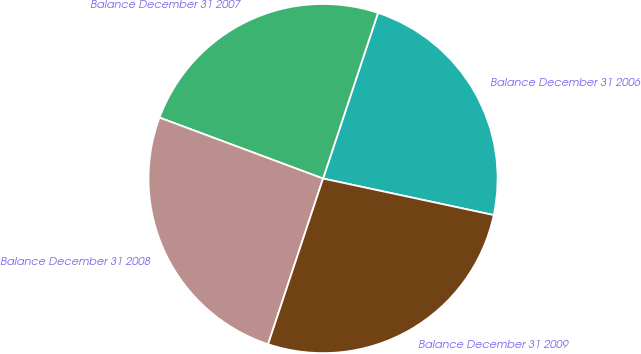<chart> <loc_0><loc_0><loc_500><loc_500><pie_chart><fcel>Balance December 31 2006<fcel>Balance December 31 2007<fcel>Balance December 31 2008<fcel>Balance December 31 2009<nl><fcel>23.26%<fcel>24.42%<fcel>25.58%<fcel>26.74%<nl></chart> 